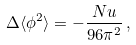<formula> <loc_0><loc_0><loc_500><loc_500>\Delta \langle \phi ^ { 2 } \rangle = - \frac { N u } { 9 6 \pi ^ { 2 } } \, ,</formula> 